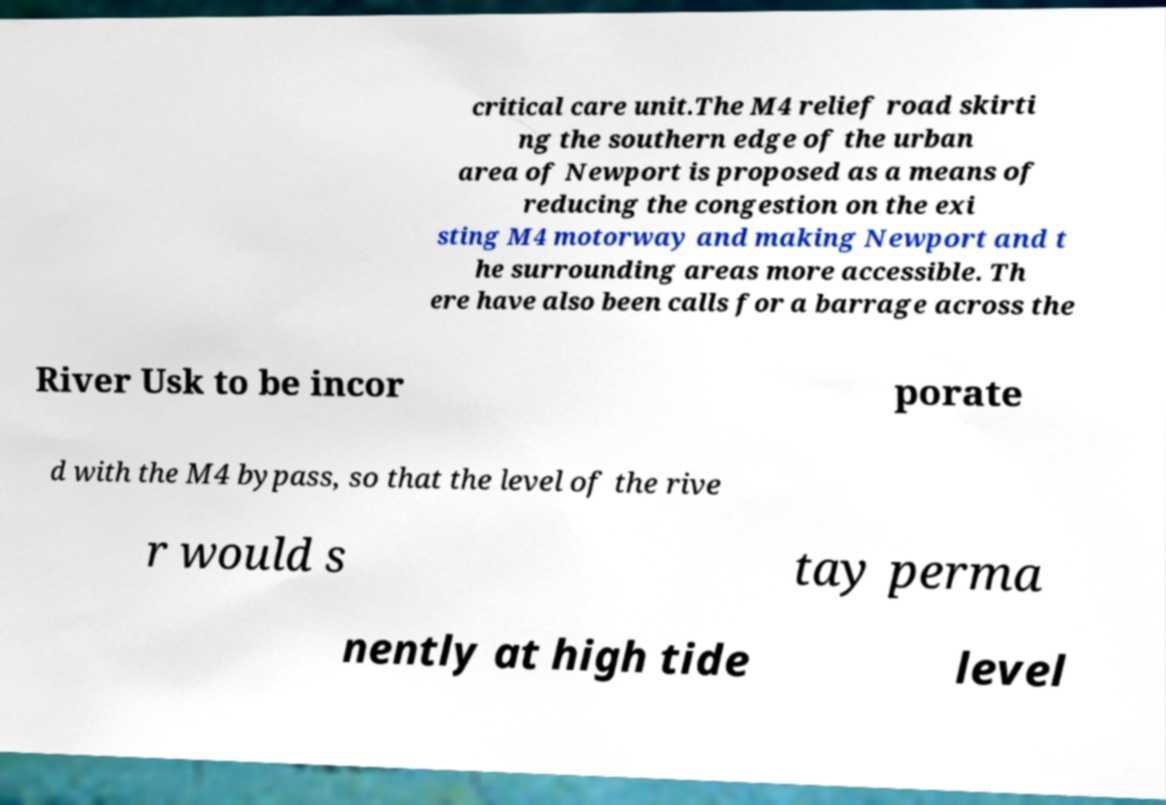Can you accurately transcribe the text from the provided image for me? critical care unit.The M4 relief road skirti ng the southern edge of the urban area of Newport is proposed as a means of reducing the congestion on the exi sting M4 motorway and making Newport and t he surrounding areas more accessible. Th ere have also been calls for a barrage across the River Usk to be incor porate d with the M4 bypass, so that the level of the rive r would s tay perma nently at high tide level 